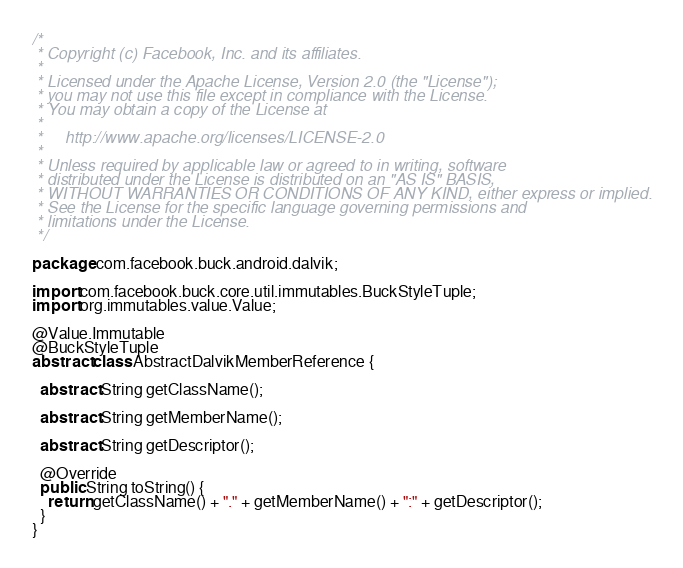<code> <loc_0><loc_0><loc_500><loc_500><_Java_>/*
 * Copyright (c) Facebook, Inc. and its affiliates.
 *
 * Licensed under the Apache License, Version 2.0 (the "License");
 * you may not use this file except in compliance with the License.
 * You may obtain a copy of the License at
 *
 *     http://www.apache.org/licenses/LICENSE-2.0
 *
 * Unless required by applicable law or agreed to in writing, software
 * distributed under the License is distributed on an "AS IS" BASIS,
 * WITHOUT WARRANTIES OR CONDITIONS OF ANY KIND, either express or implied.
 * See the License for the specific language governing permissions and
 * limitations under the License.
 */

package com.facebook.buck.android.dalvik;

import com.facebook.buck.core.util.immutables.BuckStyleTuple;
import org.immutables.value.Value;

@Value.Immutable
@BuckStyleTuple
abstract class AbstractDalvikMemberReference {

  abstract String getClassName();

  abstract String getMemberName();

  abstract String getDescriptor();

  @Override
  public String toString() {
    return getClassName() + "." + getMemberName() + ":" + getDescriptor();
  }
}
</code> 